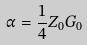Convert formula to latex. <formula><loc_0><loc_0><loc_500><loc_500>\alpha = \frac { 1 } { 4 } Z _ { 0 } G _ { 0 }</formula> 